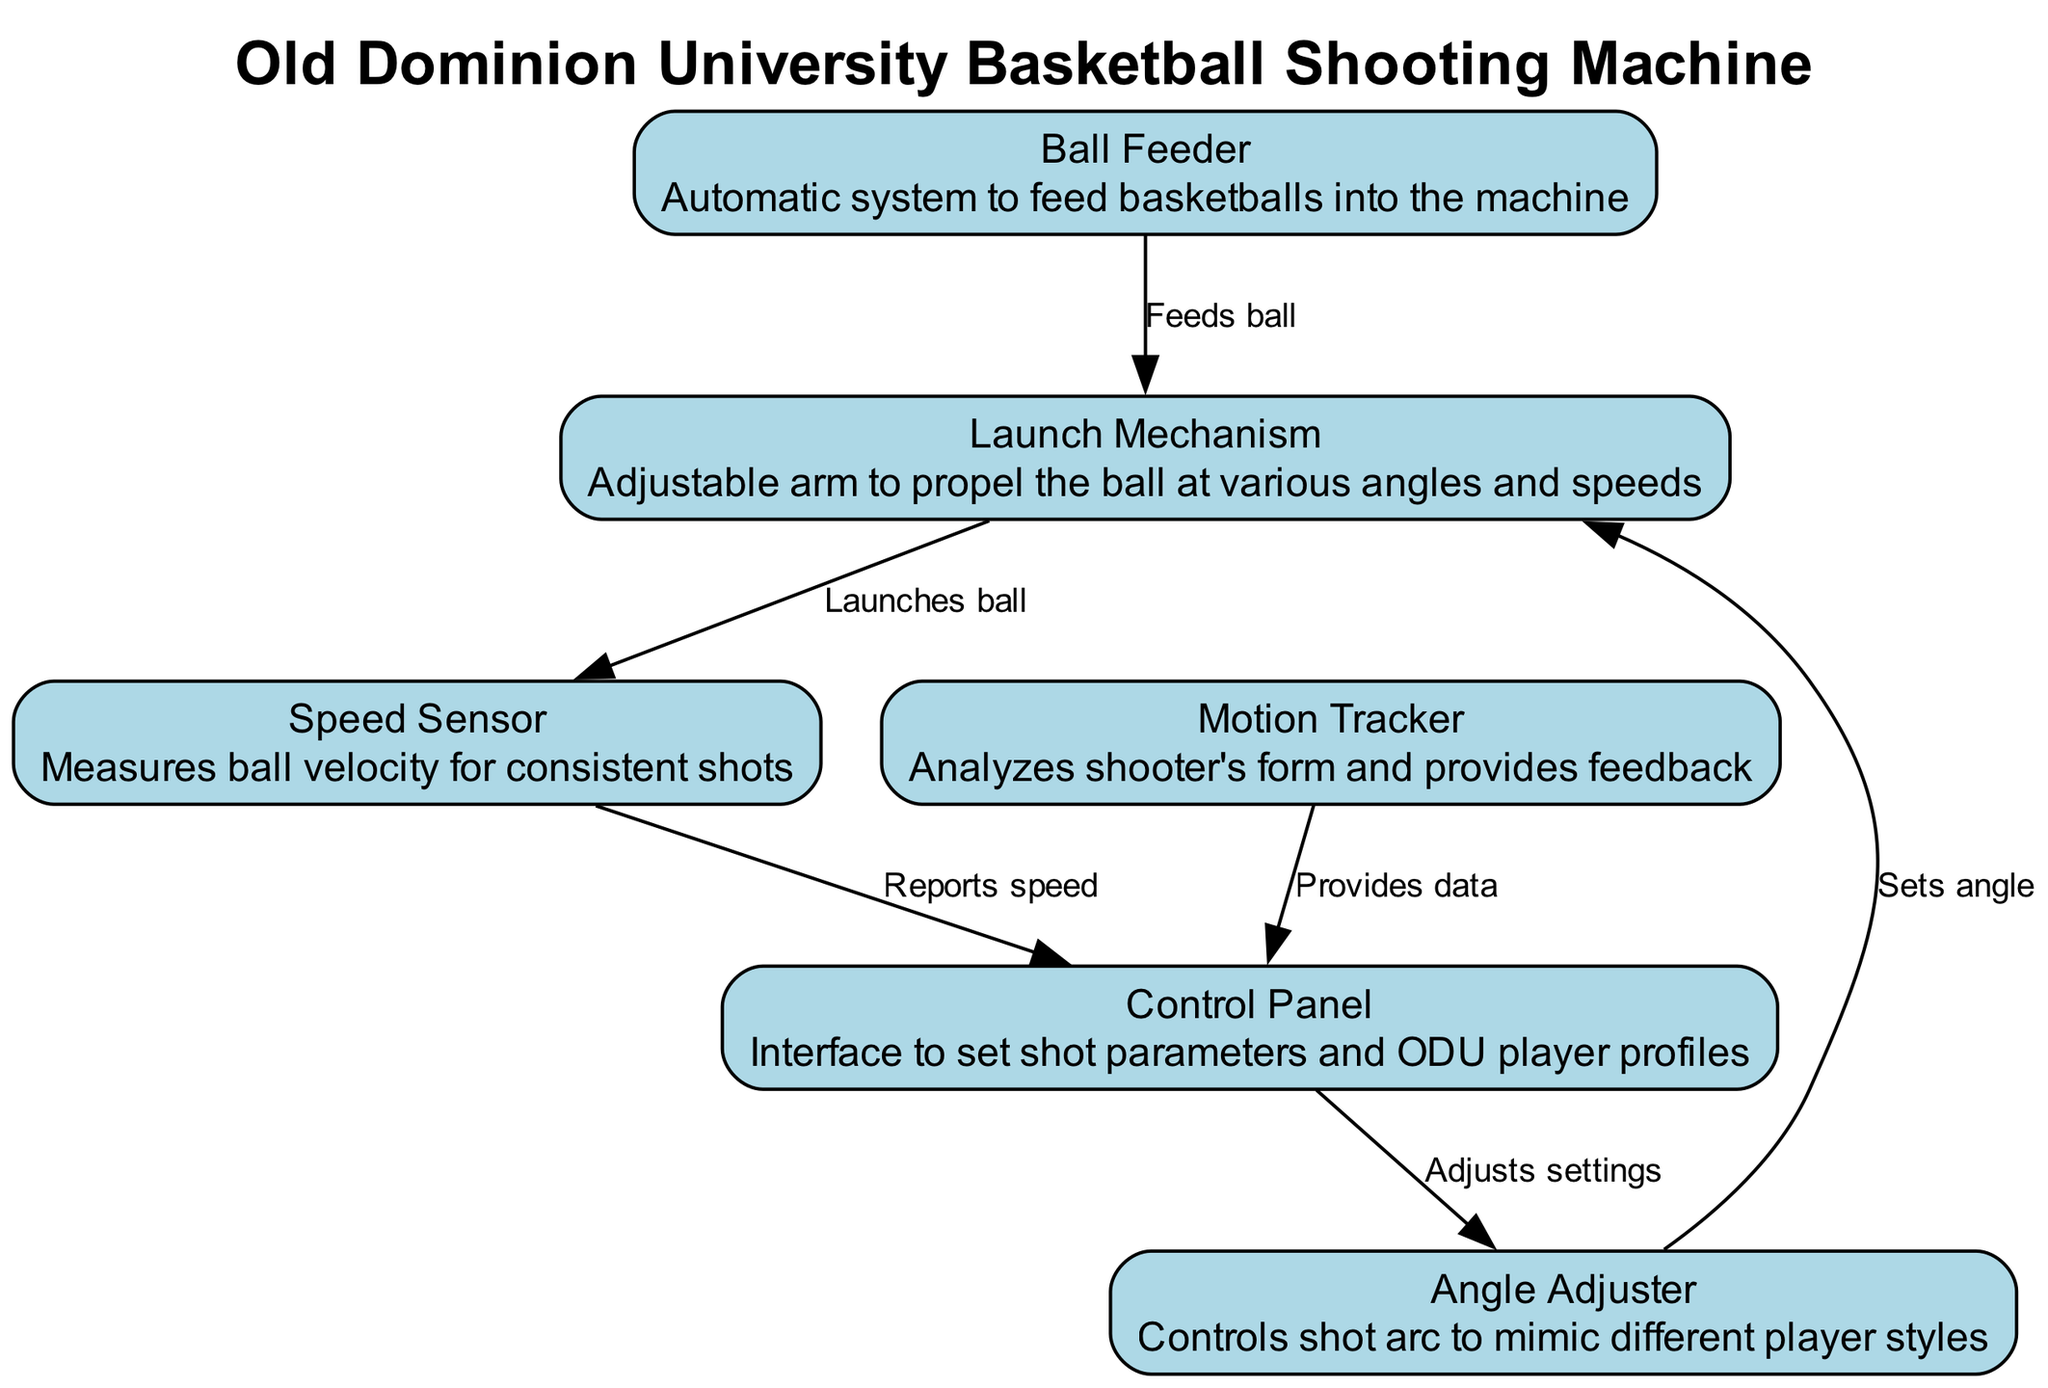What is the function of the Ball Feeder? The Ball Feeder is described as an automatic system to feed basketballs into the machine.
Answer: Automatic system to feed basketballs into the machine How many nodes are present in the diagram? The diagram lists six nodes that represent different components of the basketball shooting machine.
Answer: 6 What does the Speed Sensor provide to the Control Panel? According to the edges, the Speed Sensor reports the speed of the ball to the Control Panel for monitoring and adjustments.
Answer: Reports speed Which component adjusts the angle of shot? The Angle Adjuster specifically controls the shot arc, allowing for different player style mimicking, as stated in its description.
Answer: Angle Adjuster What is the relationship between the Motion Tracker and Control Panel? The diagram indicates that the Motion Tracker provides data to the Control Panel, which may be used for feedback and adjustments.
Answer: Provides data Which two components interact for setting the shooting angle? The edges show that the Angle Adjuster receives settings from the Control Panel, indicating a direct interaction for angle adjustment.
Answer: Control Panel and Angle Adjuster What does the Launch Mechanism do? The description indicates that the Launch Mechanism has an adjustable arm designed to propel the ball at various angles and speeds, hence its main function is to launch the ball.
Answer: Propel the ball at various angles and speeds How many edges connect the components? There are five edges in the diagram, representing the interactions and flow between the different components of the basketball shooting machine.
Answer: 5 Which component analyzes the shooter's form? The diagram clearly denotes that the Motion Tracker is responsible for analyzing the shooter's form and providing feedback based on its analysis.
Answer: Motion Tracker 